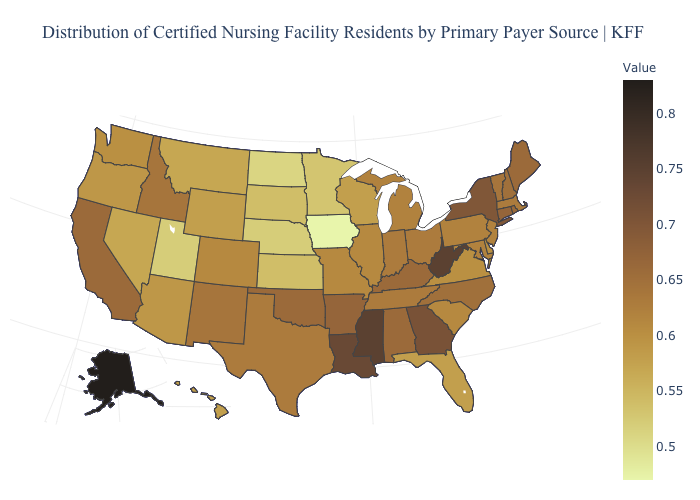Which states hav the highest value in the South?
Quick response, please. Mississippi, West Virginia. Is the legend a continuous bar?
Be succinct. Yes. Does Connecticut have a higher value than Minnesota?
Keep it brief. Yes. Does the map have missing data?
Short answer required. No. 